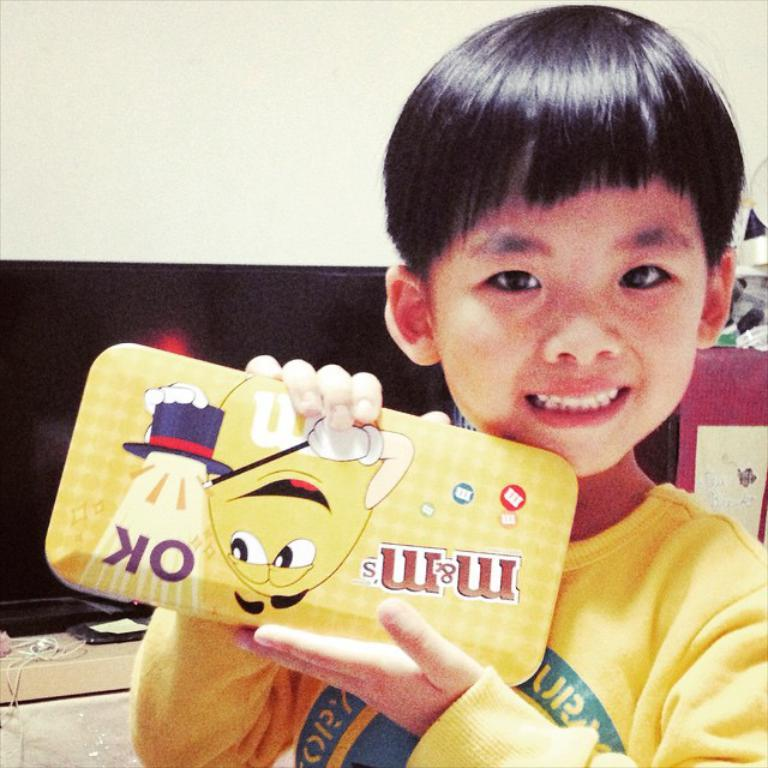What is the main subject of the image? There is a kid in the center of the image. What is the kid doing in the image? The kid is smiling. What is the kid holding in the image? The kid is holding a box. What can be seen in the background of the image? There is a wall, a black color object, and a few other objects in the background of the image. What type of finger can be seen in the image? There are no fingers visible in the image. What is the voice of the kid in the image? The image is a still picture, so there is no voice present. 